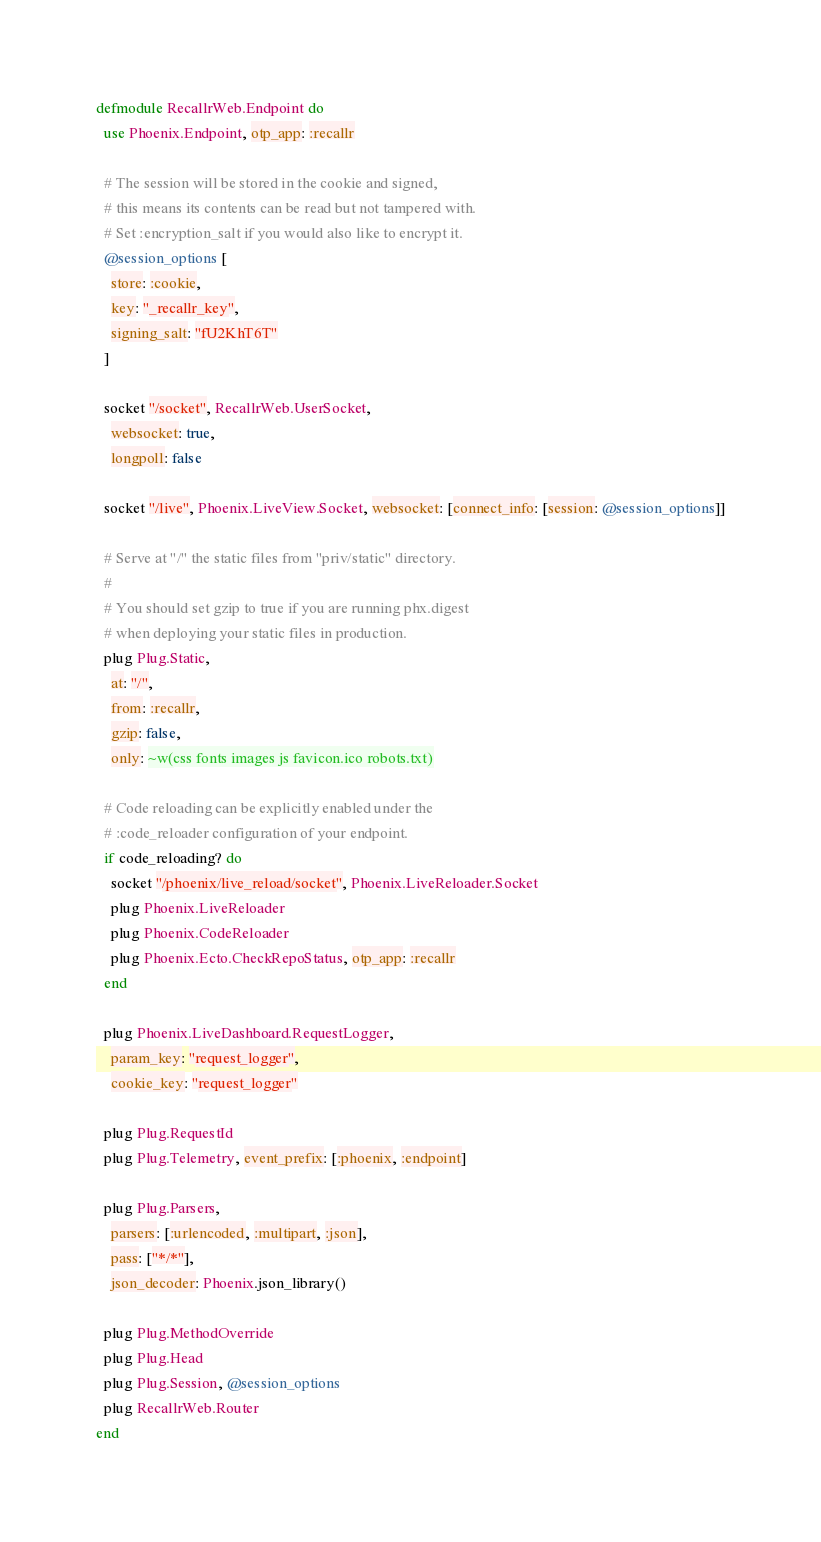<code> <loc_0><loc_0><loc_500><loc_500><_Elixir_>defmodule RecallrWeb.Endpoint do
  use Phoenix.Endpoint, otp_app: :recallr

  # The session will be stored in the cookie and signed,
  # this means its contents can be read but not tampered with.
  # Set :encryption_salt if you would also like to encrypt it.
  @session_options [
    store: :cookie,
    key: "_recallr_key",
    signing_salt: "fU2KhT6T"
  ]

  socket "/socket", RecallrWeb.UserSocket,
    websocket: true,
    longpoll: false

  socket "/live", Phoenix.LiveView.Socket, websocket: [connect_info: [session: @session_options]]

  # Serve at "/" the static files from "priv/static" directory.
  #
  # You should set gzip to true if you are running phx.digest
  # when deploying your static files in production.
  plug Plug.Static,
    at: "/",
    from: :recallr,
    gzip: false,
    only: ~w(css fonts images js favicon.ico robots.txt)

  # Code reloading can be explicitly enabled under the
  # :code_reloader configuration of your endpoint.
  if code_reloading? do
    socket "/phoenix/live_reload/socket", Phoenix.LiveReloader.Socket
    plug Phoenix.LiveReloader
    plug Phoenix.CodeReloader
    plug Phoenix.Ecto.CheckRepoStatus, otp_app: :recallr
  end

  plug Phoenix.LiveDashboard.RequestLogger,
    param_key: "request_logger",
    cookie_key: "request_logger"

  plug Plug.RequestId
  plug Plug.Telemetry, event_prefix: [:phoenix, :endpoint]

  plug Plug.Parsers,
    parsers: [:urlencoded, :multipart, :json],
    pass: ["*/*"],
    json_decoder: Phoenix.json_library()

  plug Plug.MethodOverride
  plug Plug.Head
  plug Plug.Session, @session_options
  plug RecallrWeb.Router
end
</code> 